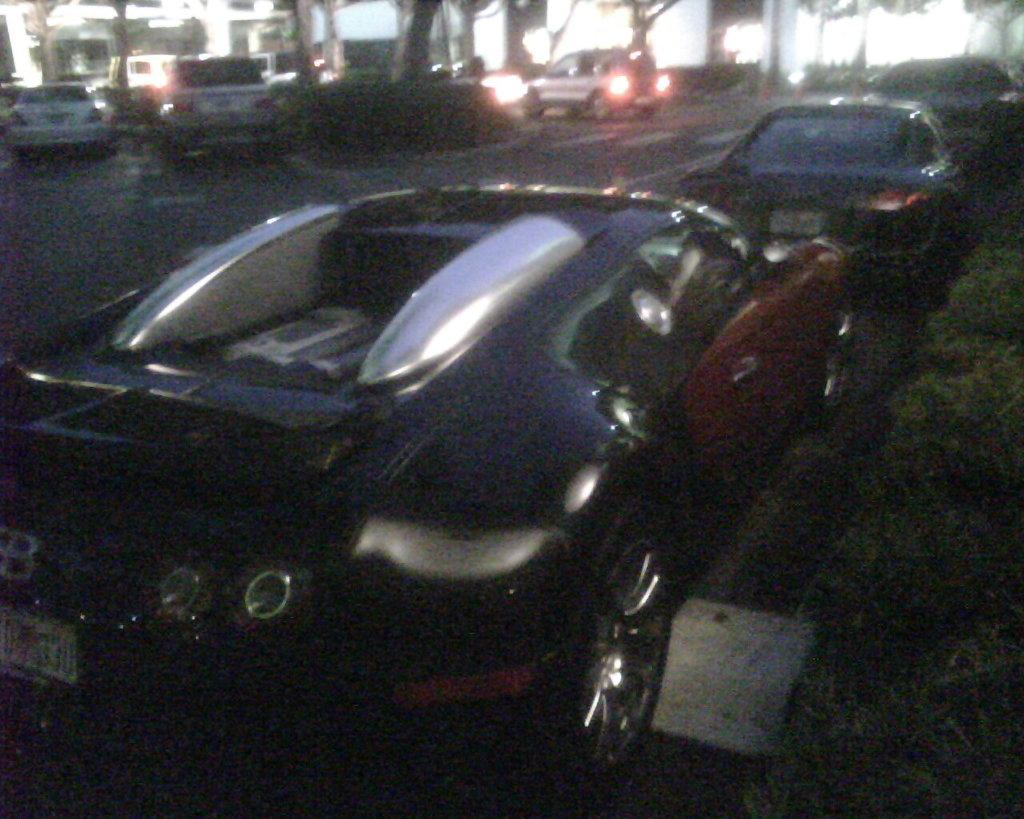What type of vehicles can be seen on the road in the image? There are cars on the road in the image. What is the profit made by the train in the image? There is no train present in the image, so it is not possible to determine the profit made by a train. 